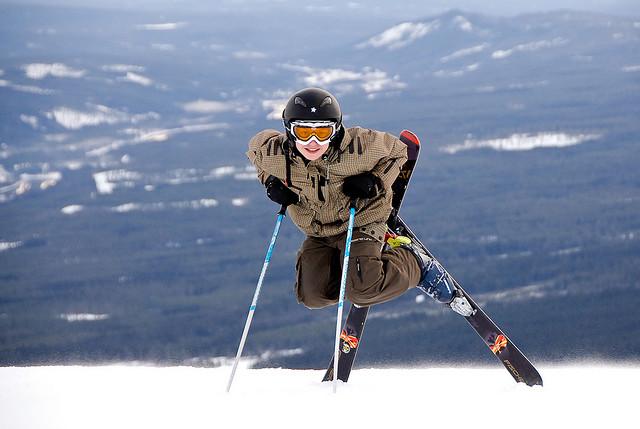Is the person flying?
Short answer required. No. Is the boy skiing properly?
Short answer required. No. Does the boy look excited?
Write a very short answer. Yes. 